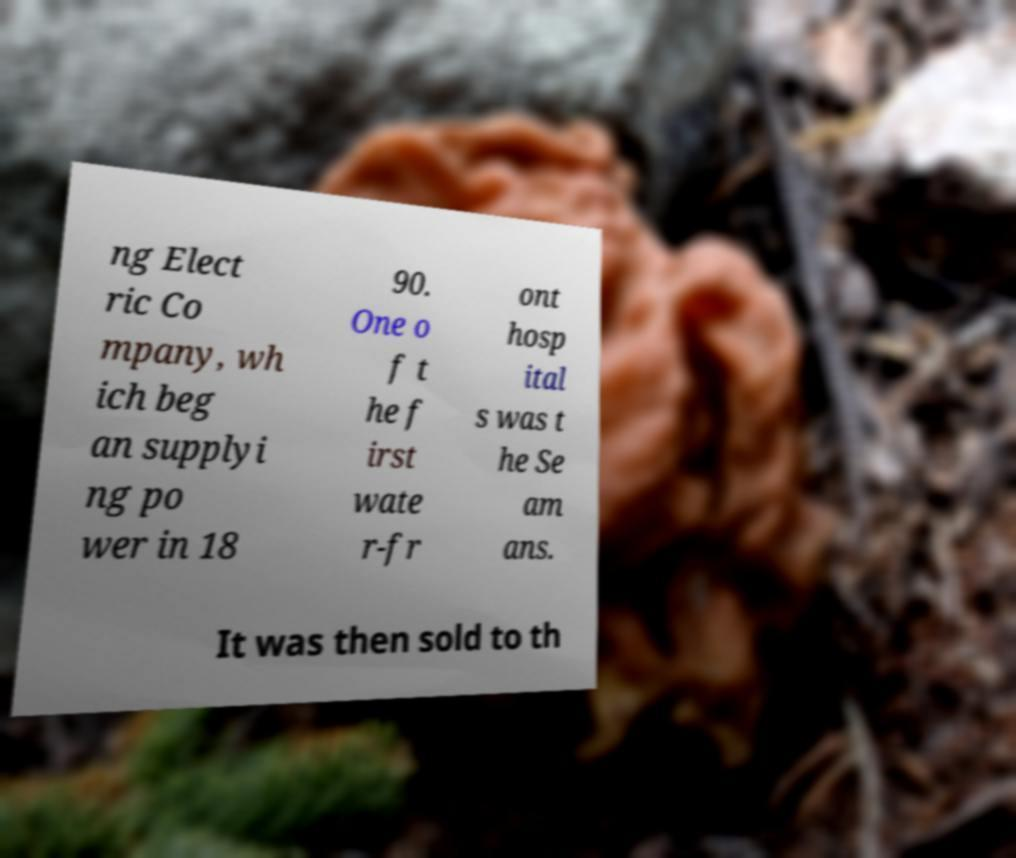Could you assist in decoding the text presented in this image and type it out clearly? ng Elect ric Co mpany, wh ich beg an supplyi ng po wer in 18 90. One o f t he f irst wate r-fr ont hosp ital s was t he Se am ans. It was then sold to th 